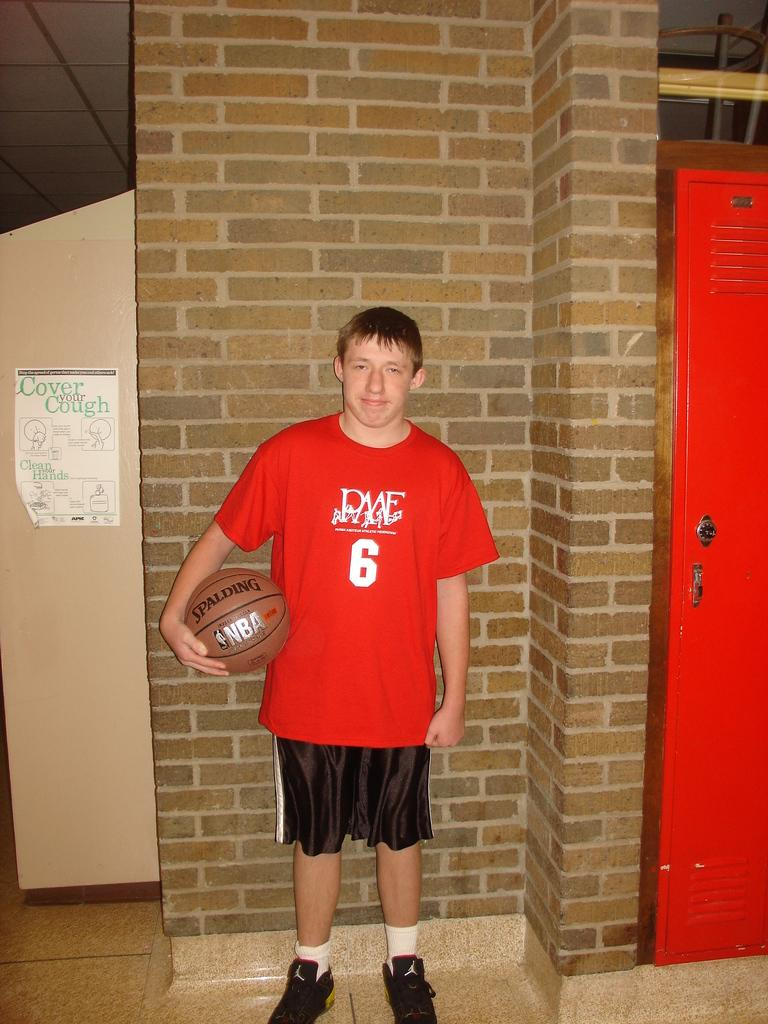<image>
Relay a brief, clear account of the picture shown. A very saturated shot of basketball player number 6 against a brick wall 